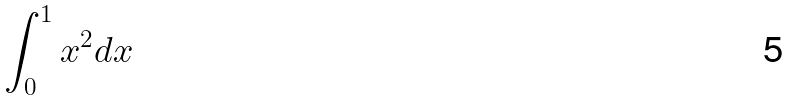Convert formula to latex. <formula><loc_0><loc_0><loc_500><loc_500>\int _ { 0 } ^ { 1 } x ^ { 2 } d x</formula> 